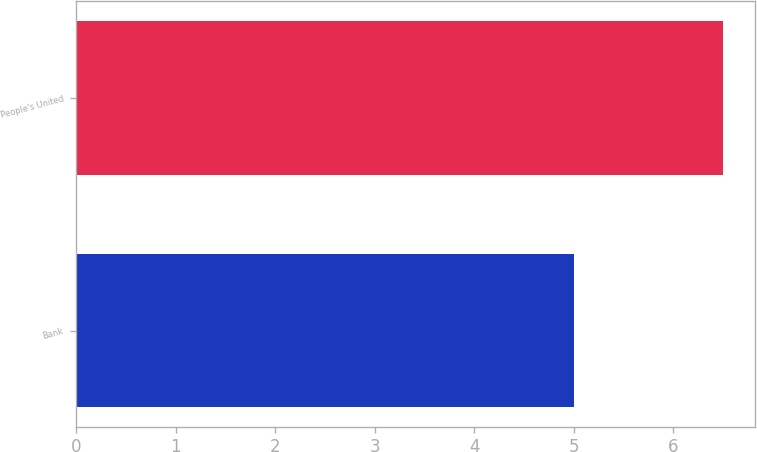Convert chart. <chart><loc_0><loc_0><loc_500><loc_500><bar_chart><fcel>Bank<fcel>People's United<nl><fcel>5<fcel>6.5<nl></chart> 